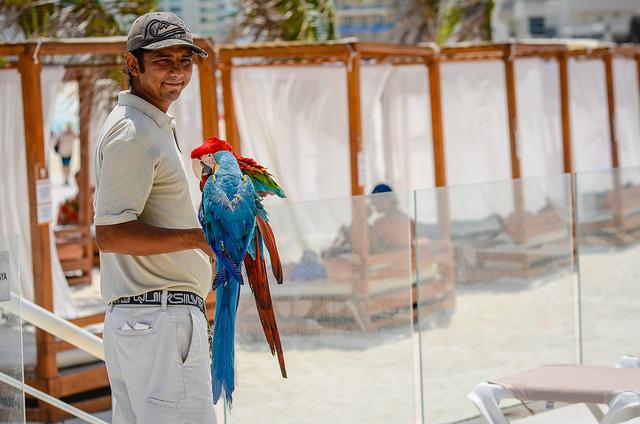What is the man holding?
Quick response, please. Parrot. How many birds is the man holding?
Answer briefly. 2. Does the man enjoy being crapped on by the birds?
Be succinct. No. 